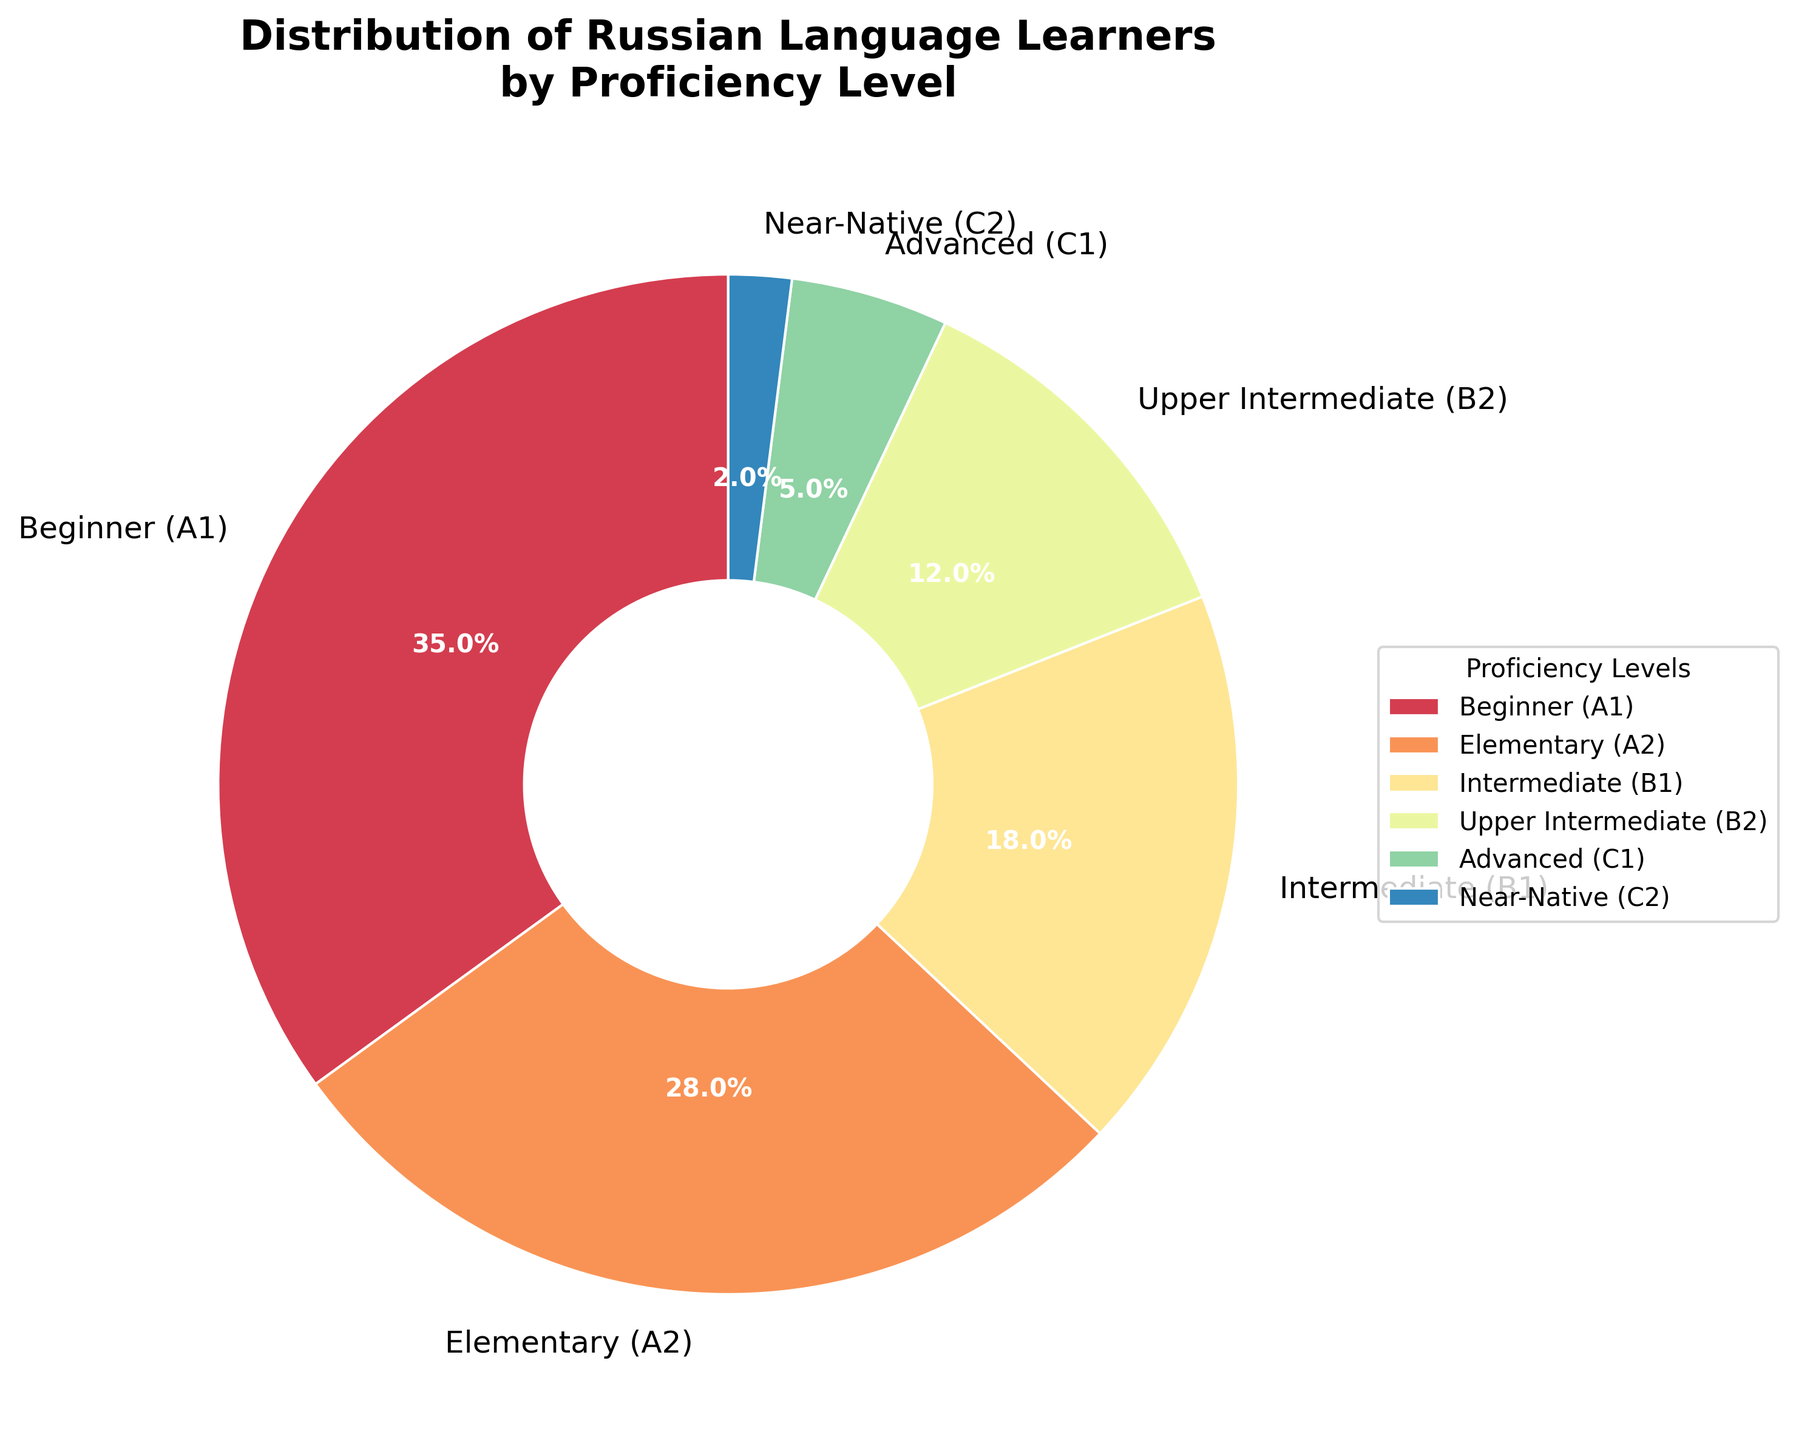What percentage of learners are in the Beginner (A1) and Elementary (A2) levels combined? Sum the percentages of Beginner (A1) and Elementary (A2). Beginner (A1) is 35% and Elementary (A2) is 28%, so 35 + 28 = 63%.
Answer: 63% Which proficiency level has the least number of learners? The figure shows that Near-Native (C2) has the smallest percentage at 2%.
Answer: Near-Native (C2) How many percentage points more learners are at the Beginner (A1) level compared to the Advanced (C1) level? Subtract the percentage of Advanced (C1) learners from Beginner (A1) learners. Beginner (A1) is 35%, and Advanced (C1) is 5%, so 35 - 5 = 30 percentage points.
Answer: 30 percentage points What's the most common proficiency level among the learners? The largest slice of the pie chart represents 35% for the Beginner (A1) level.
Answer: Beginner (A1) Which two levels combined make up less than 10% of learners? Both Advanced (C1) at 5% and Near-Native (C2) at 2% combined (5 + 2 = 7%) make up less than 10%.
Answer: Advanced (C1) and Near-Native (C2) Are there more learners at the Beginner (A1) level than at the Intermediate (B1) and Upper Intermediate (B2) levels combined? Sum the percentages of Intermediate (B1) and Upper Intermediate (B2) and compare with Beginner (A1). Intermediate (B1) is 18% and Upper Intermediate (B2) is 12%, so 18 + 12 = 30%. Beginner (A1) is 35%, which is greater than 30%.
Answer: Yes Which proficiency levels have more than 20% of the learners? From the pie chart, only Beginner (A1) with 35% and Elementary (A2) with 28% have more than 20%.
Answer: Beginner (A1) and Elementary (A2) What is the difference in percentage between learners at the Intermediate (B1) level and the Elementary (A2) level? Subtract the percentage of Intermediate (B1) learners from Elementary (A2) learners. Elementary (A2) is 28% and Intermediate (B1) is 18%, so 28 - 18 = 10%.
Answer: 10% What visual element highlights the difference between various proficiency levels in the chart? The pie slices of varying sizes and distinct colors are the visual elements that highlight the differences between proficiency levels.
Answer: Pie slices with colors Which proficiency levels are represented by dark colors in the pie chart? Observe the colors in the pie chart. The levels with darker colors are Upper Intermediate (B2) and Advanced (C1).
Answer: Upper Intermediate (B2) and Advanced (C1) 